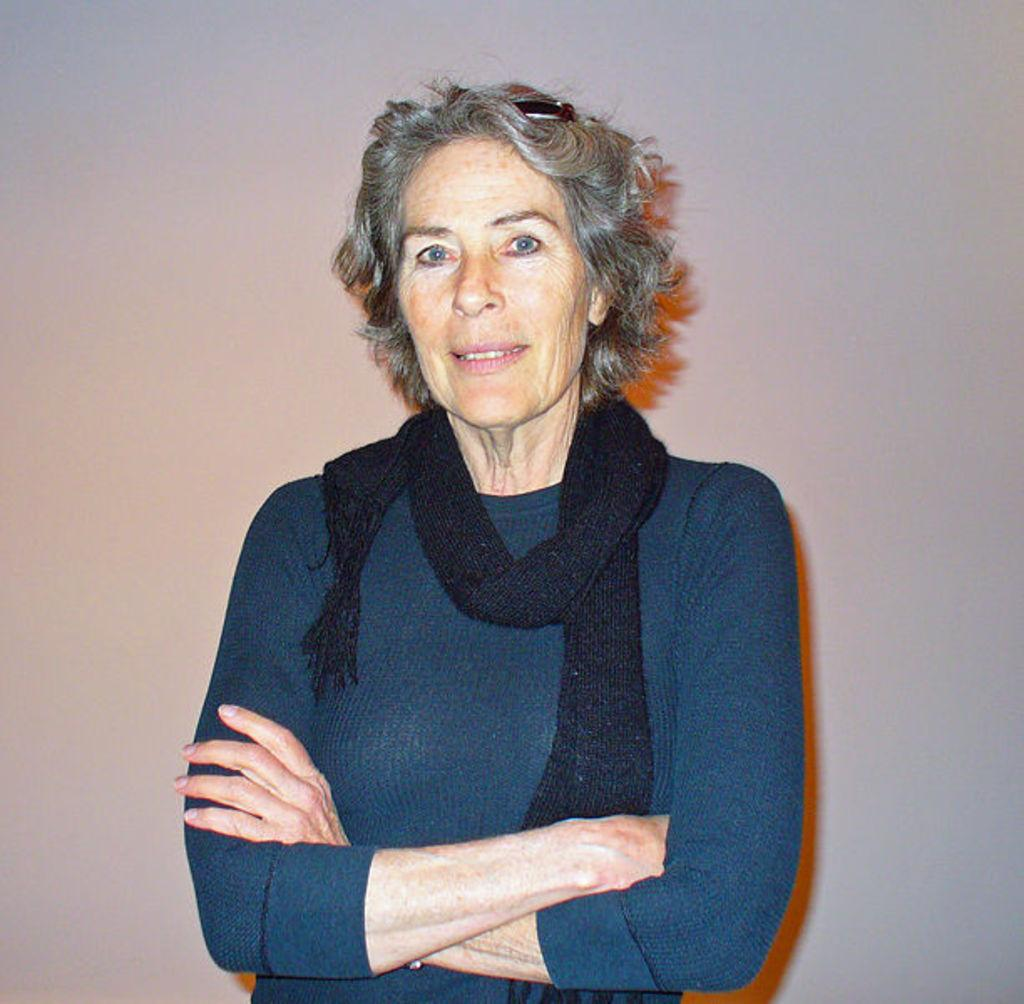What is the main subject of the image? There is a person in the image. What is the person wearing? The person is wearing a blue dress and a black scarf. Can you describe the background of the image? The background of the image is ash-colored. How many geese are visible in the image? There are no geese present in the image. Is there a bed in the image? There is no bed visible in the image. 